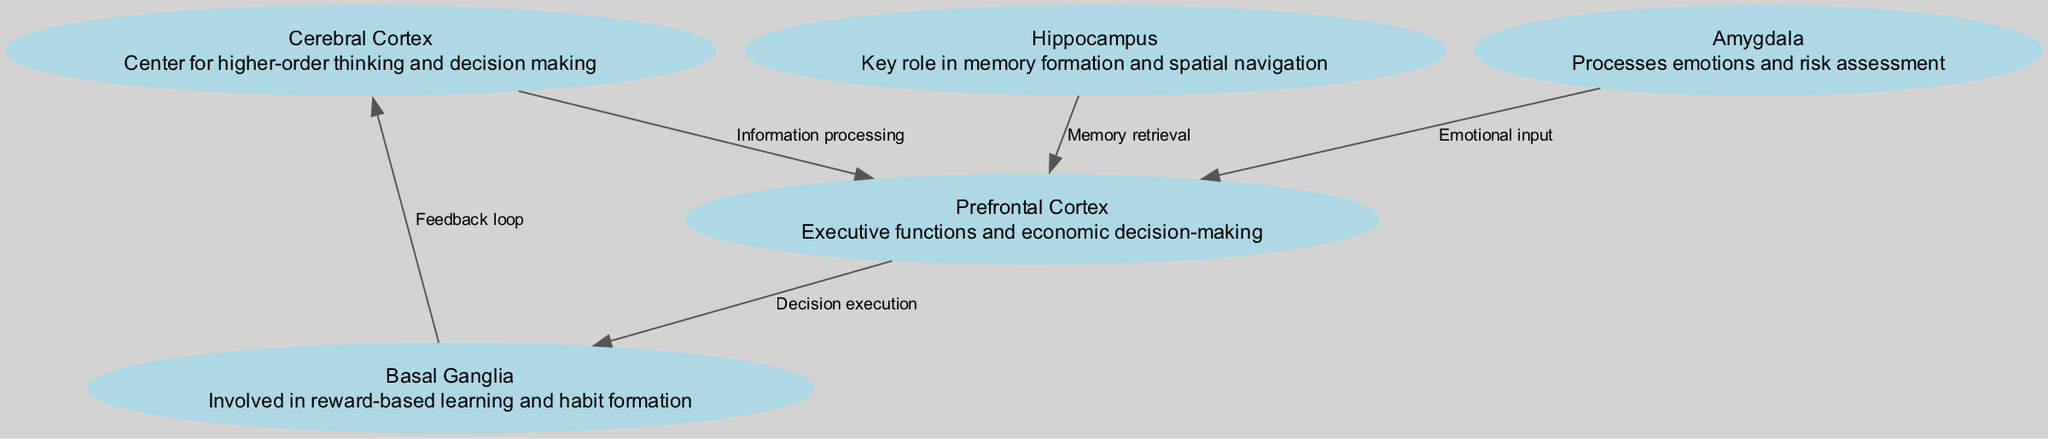What is the id of the Hippocampus node? Each node in the diagram has a unique identifier (id). The Hippocampus is represented as node 2 in the provided data.
Answer: 2 How many nodes are present in the diagram? The diagram shows various brain regions, and from the data, we can count a total of five distinct nodes listed.
Answer: 5 What is the relationship between the Cerebral Cortex and the Prefrontal Cortex? The edge connections illustrate the flow of information processing, and there is an edge labeled "Information processing" going from the Cerebral Cortex to the Prefrontal Cortex.
Answer: Information processing Which node processes emotional input? By reviewing the connections, the edge from the Amygdala to the Prefrontal Cortex is labeled "Emotional input," indicating that the Amygdala processes emotions.
Answer: Amygdala What is the role of the Basal Ganglia in this model? The description associated with the Basal Ganglia specifies that it is involved in reward-based learning and habit formation, highlighting its importance in the overall network.
Answer: Reward-based learning and habit formation If information flows from the Prefrontal Cortex to the Basal Ganglia, what can be inferred about decision making? The diagram includes a directed edge labeled "Decision execution" from the Prefrontal Cortex to the Basal Ganglia, indicating that the Prefrontal Cortex is responsible for executing decisions based on processed information.
Answer: Decision execution What is the feedback loop in this neural model? The diagram shows an edge labeled "Feedback loop" that connects the Basal Ganglia back to the Cerebral Cortex. This suggests that the output from the Basal Ganglia influences further processing in the Cerebral Cortex.
Answer: Feedback loop Which brain region is associated with memory retrieval? Referring to the edges, the edge from the Hippocampus to the Prefrontal Cortex is labeled "Memory retrieval," indicating the Hippocampus's primary association with memory processes in this model.
Answer: Hippocampus 